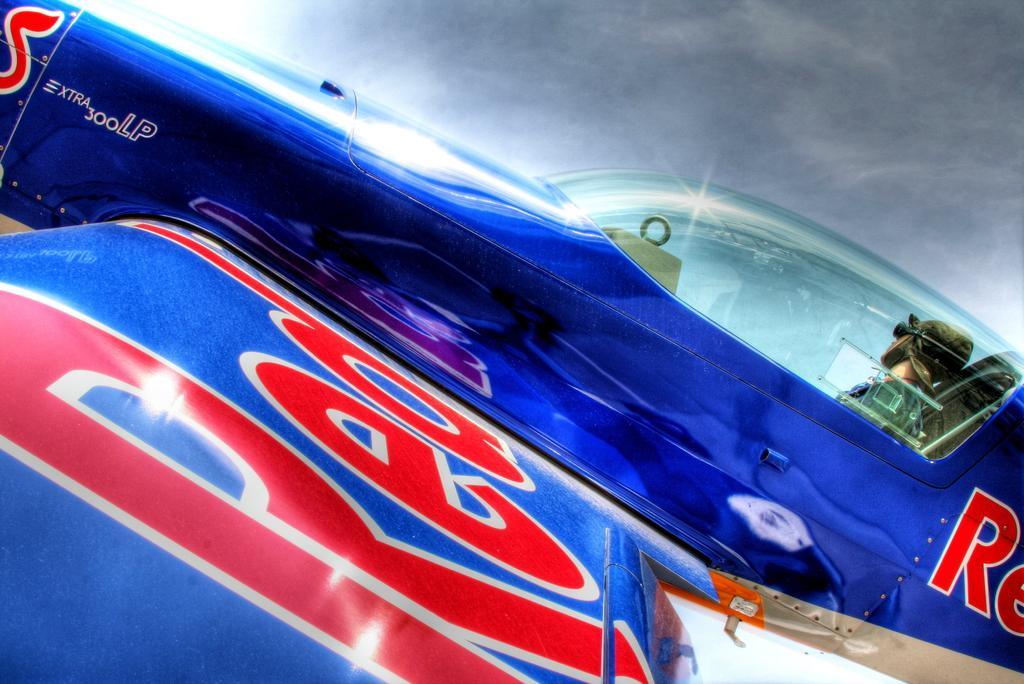<image>
Write a terse but informative summary of the picture. A blue and red plane has the word Red written on it. 